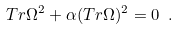<formula> <loc_0><loc_0><loc_500><loc_500>T r { \Omega } ^ { 2 } + { \alpha } ( T r { \Omega } ) ^ { 2 } = 0 \ .</formula> 